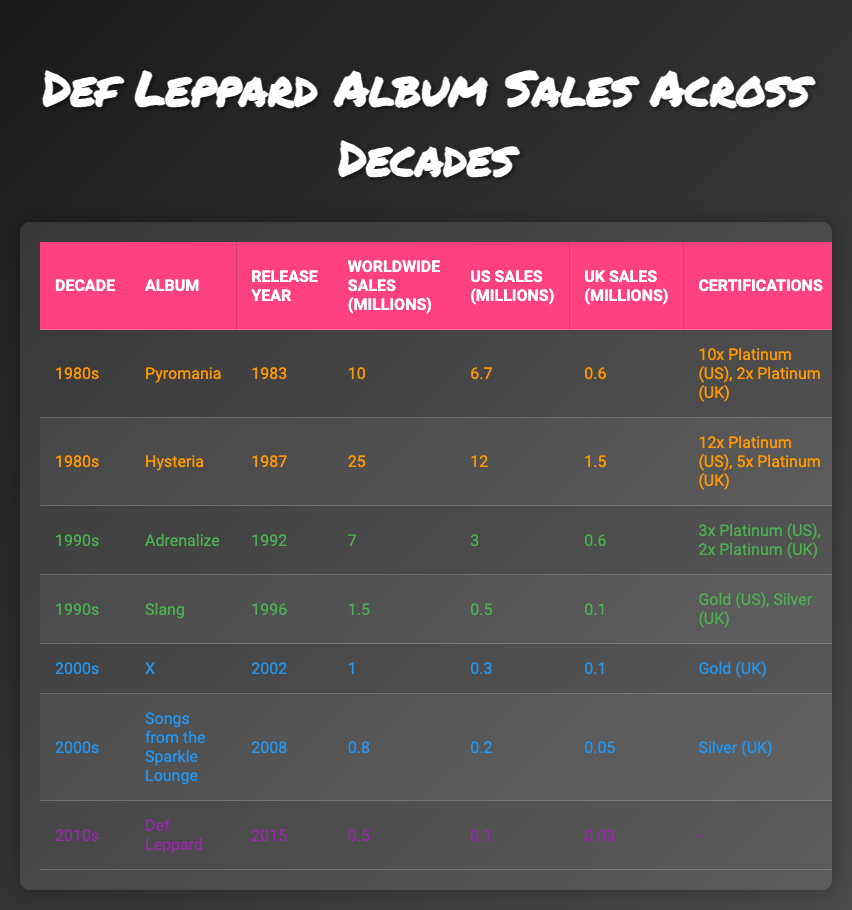What was the best-selling album of Def Leppard in the 1980s? The table shows that "Hysteria," released in 1987, has the highest worldwide sales of 25 million during the 1980s.
Answer: Hysteria How many albums did Def Leppard release in the 1990s? According to the table, there are two albums listed from the 1990s: "Adrenalize" and "Slang."
Answer: 2 What is the total worldwide sales of all albums released in the 2000s? The worldwide sales for albums in the 2000s are "X" with 1 million and "Songs from the Sparkle Lounge" with 0.8 million. Summing them gives 1 + 0.8 = 1.8 million.
Answer: 1.8 million Did "Pyromania" achieve more US sales than "Adrenalize"? Yes, "Pyromania" had US sales of 6.7 million, while "Adrenalize" had 3 million, so "Pyromania" sold more.
Answer: Yes What is the average UK sales for the albums released in the 1980s? The UK sales for "Pyromania" is 0.6 million and for "Hysteria" is 1.5 million. The total is 0.6 + 1.5 = 2.1 million. There are 2 albums, so average UK sales = 2.1 / 2 = 1.05 million.
Answer: 1.05 million Which album had the least worldwide sales across all decades? The album with the least worldwide sales is "Slang," with only 1.5 million sales.
Answer: Slang How do the certifications of the album "Hysteria" compare to those of "Adrenalize"? "Hysteria" has certifications of 12x Platinum (US), 5x Platinum (UK), while "Adrenalize" has 3x Platinum (US), 2x Platinum (UK). This indicates that "Hysteria" is certified higher than "Adrenalize."
Answer: Hysteria is certified higher What was the US sales difference between "Def Leppard" and "X"? "Def Leppard" had US sales of 0.1 million, while "X" had 0.3 million. The difference is 0.3 - 0.1 = 0.2 million.
Answer: 0.2 million Which decade had the highest overall sales for Def Leppard albums? The 1980s had the highest represented by the albums "Pyromania" and "Hysteria," with total worldwide sales of 35 million (10 + 25).
Answer: 1980s 